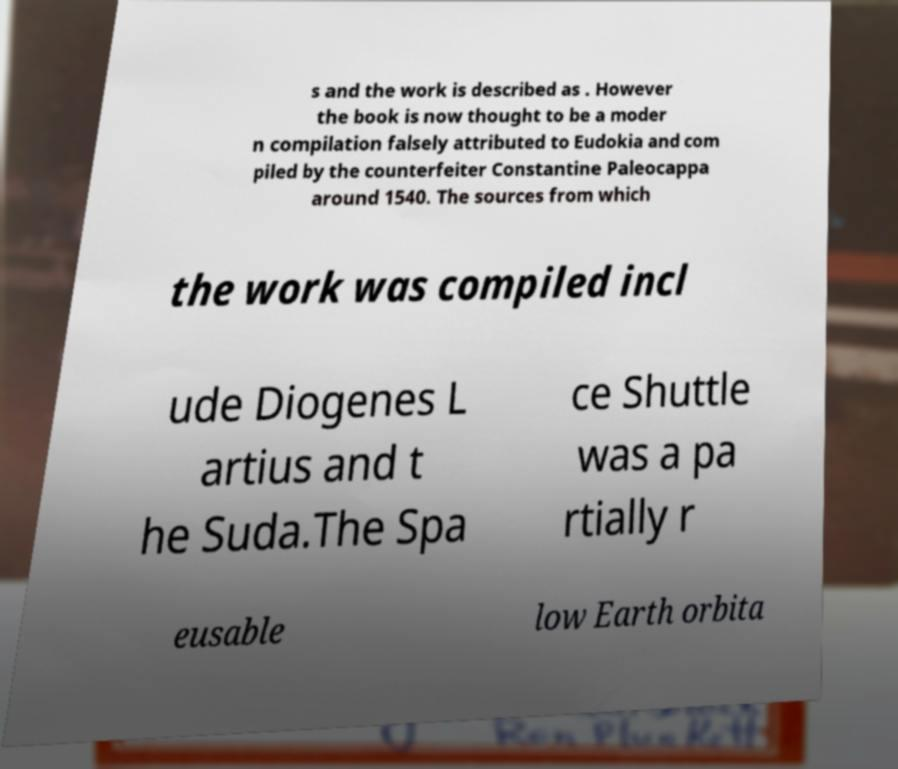Can you accurately transcribe the text from the provided image for me? s and the work is described as . However the book is now thought to be a moder n compilation falsely attributed to Eudokia and com piled by the counterfeiter Constantine Paleocappa around 1540. The sources from which the work was compiled incl ude Diogenes L artius and t he Suda.The Spa ce Shuttle was a pa rtially r eusable low Earth orbita 